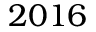<formula> <loc_0><loc_0><loc_500><loc_500>2 0 1 6</formula> 